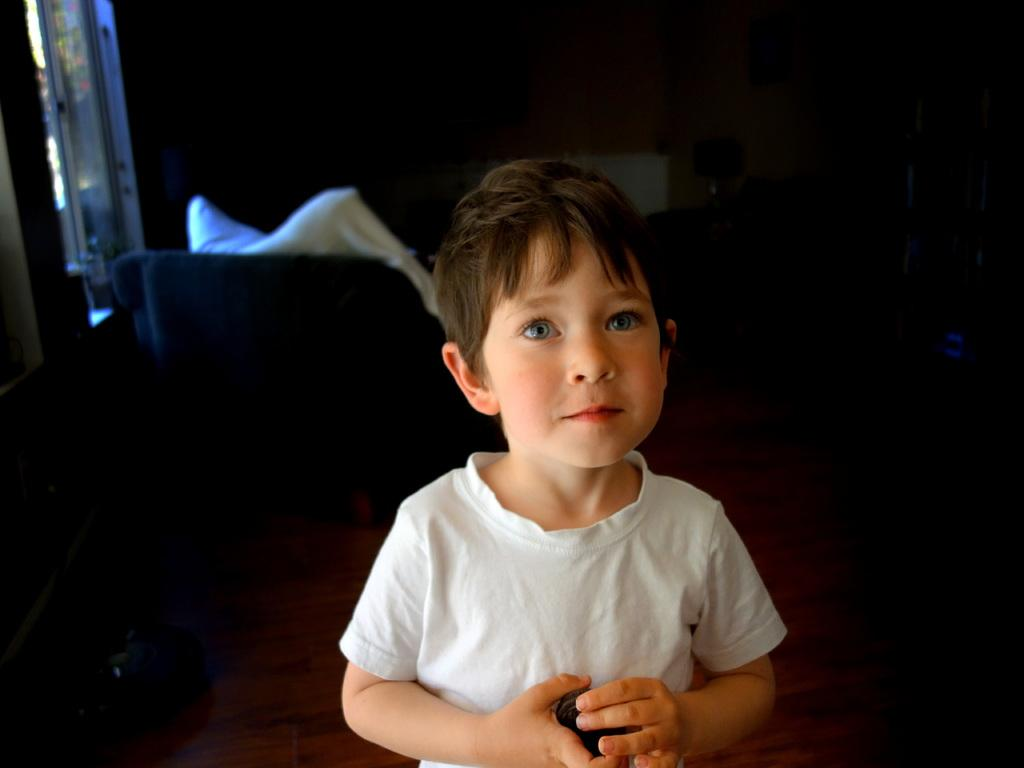What is the main subject of the image? The main subject of the image is a kid. What is the kid wearing in the image? The kid is wearing a white T-shirt. What is the kid's posture in the image? The kid is standing. How many eggs are visible in the image? There are no eggs present in the image. What type of lead is the kid holding in the image? There is no lead present in the image, and the kid is not holding anything. 